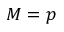Convert formula to latex. <formula><loc_0><loc_0><loc_500><loc_500>M = p</formula> 